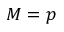Convert formula to latex. <formula><loc_0><loc_0><loc_500><loc_500>M = p</formula> 